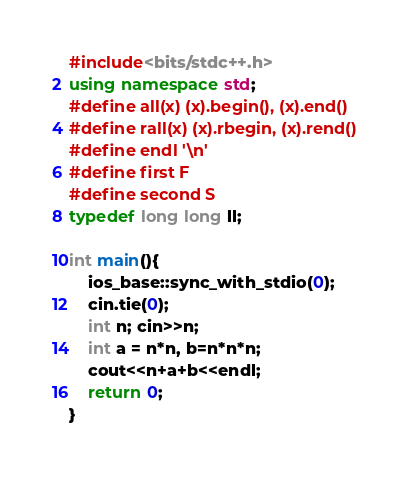<code> <loc_0><loc_0><loc_500><loc_500><_C++_>#include<bits/stdc++.h>
using namespace std;
#define all(x) (x).begin(), (x).end()
#define rall(x) (x).rbegin, (x).rend()
#define endl '\n'
#define first F
#define second S
typedef long long ll;

int main(){
	ios_base::sync_with_stdio(0);
	cin.tie(0);
	int n; cin>>n;
	int a = n*n, b=n*n*n;
	cout<<n+a+b<<endl;
	return 0;
}
</code> 